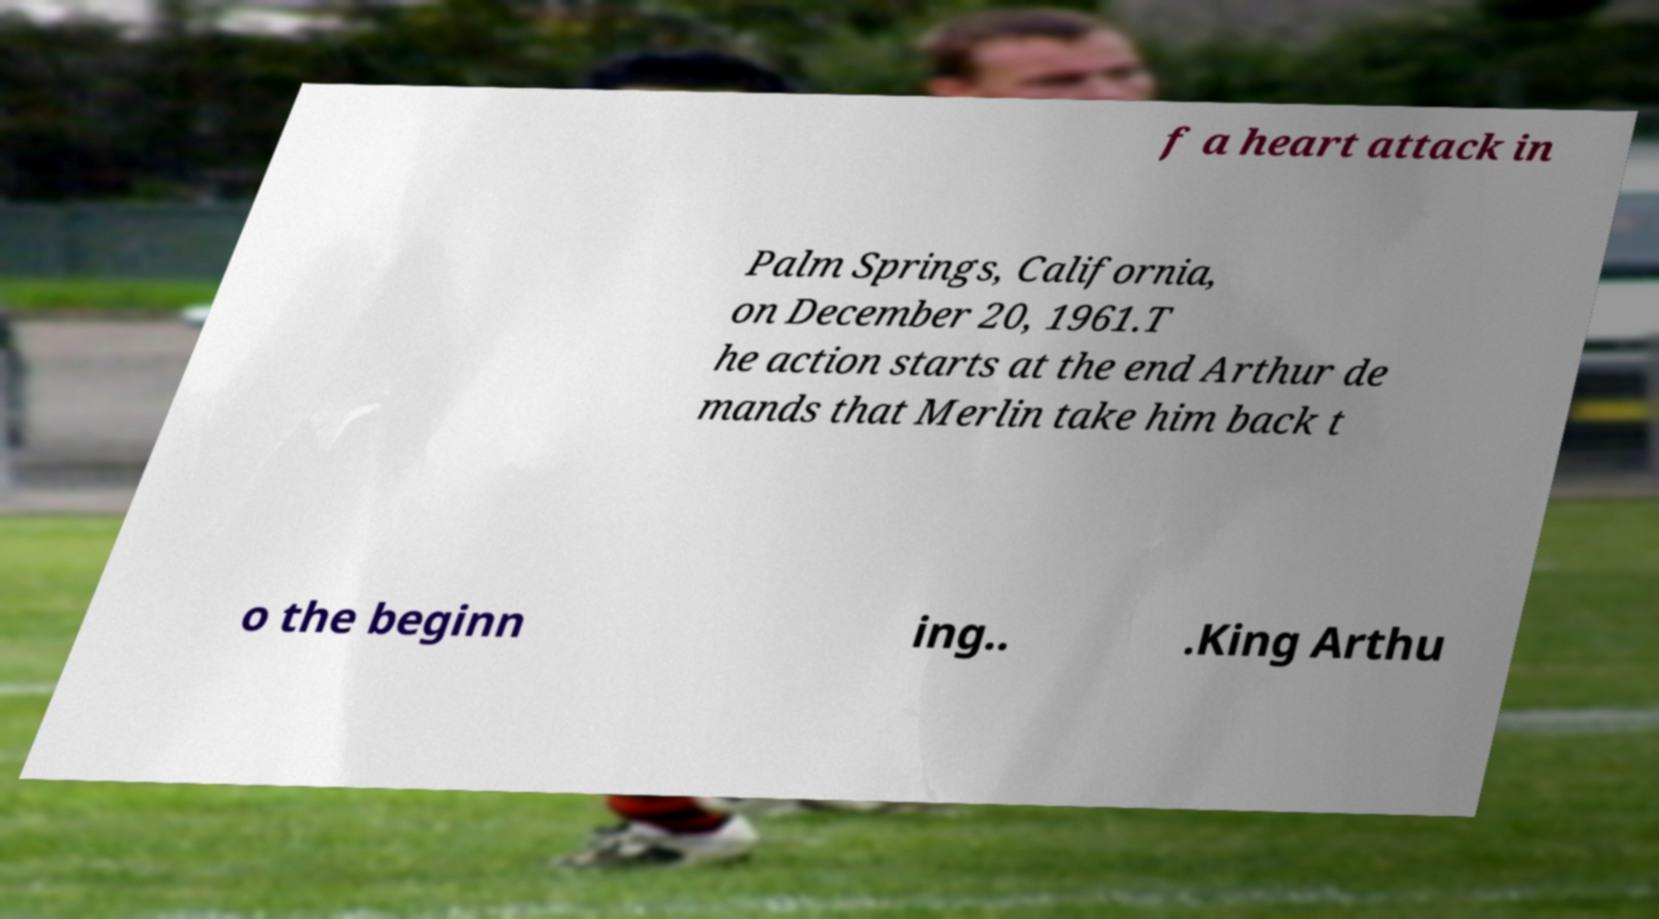Can you read and provide the text displayed in the image?This photo seems to have some interesting text. Can you extract and type it out for me? f a heart attack in Palm Springs, California, on December 20, 1961.T he action starts at the end Arthur de mands that Merlin take him back t o the beginn ing.. .King Arthu 